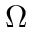<formula> <loc_0><loc_0><loc_500><loc_500>\Omega</formula> 